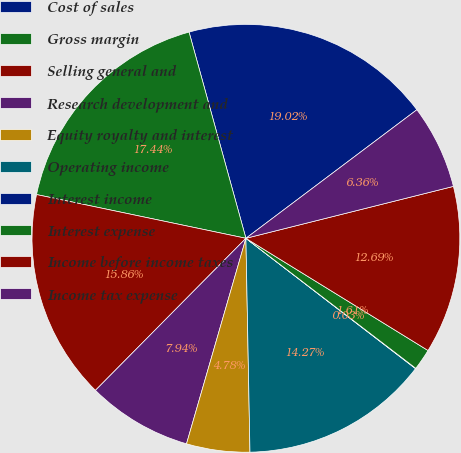<chart> <loc_0><loc_0><loc_500><loc_500><pie_chart><fcel>Cost of sales<fcel>Gross margin<fcel>Selling general and<fcel>Research development and<fcel>Equity royalty and interest<fcel>Operating income<fcel>Interest income<fcel>Interest expense<fcel>Income before income taxes<fcel>Income tax expense<nl><fcel>19.02%<fcel>17.44%<fcel>15.86%<fcel>7.94%<fcel>4.78%<fcel>14.27%<fcel>0.03%<fcel>1.61%<fcel>12.69%<fcel>6.36%<nl></chart> 